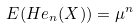<formula> <loc_0><loc_0><loc_500><loc_500>E ( H e _ { n } ( X ) ) = \mu ^ { n }</formula> 